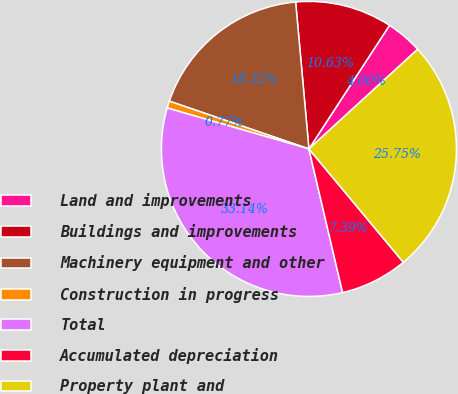Convert chart to OTSL. <chart><loc_0><loc_0><loc_500><loc_500><pie_chart><fcel>Land and improvements<fcel>Buildings and improvements<fcel>Machinery equipment and other<fcel>Construction in progress<fcel>Total<fcel>Accumulated depreciation<fcel>Property plant and<nl><fcel>4.0%<fcel>10.63%<fcel>18.32%<fcel>0.77%<fcel>33.14%<fcel>7.39%<fcel>25.75%<nl></chart> 